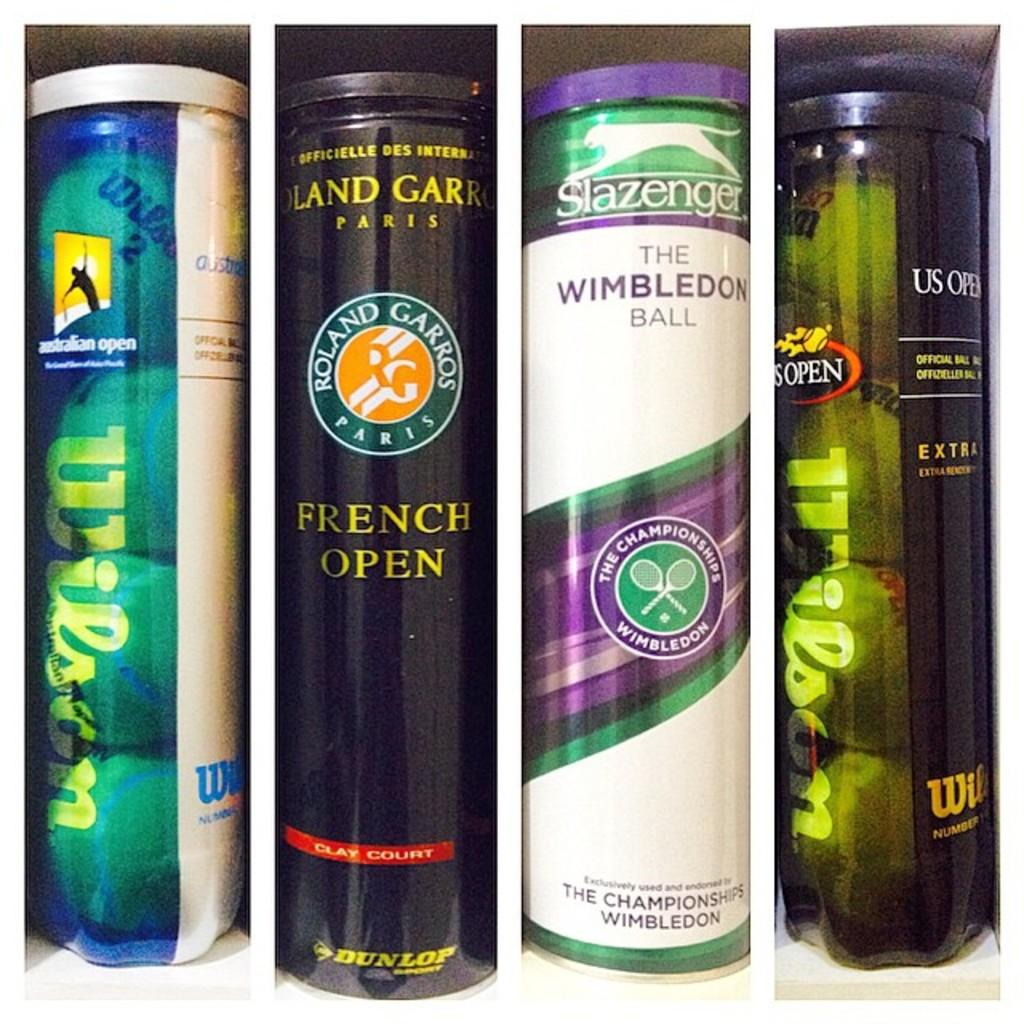<image>
Share a concise interpretation of the image provided. A can of Roland Garros tennis balls sits in a box with a few other brands. 